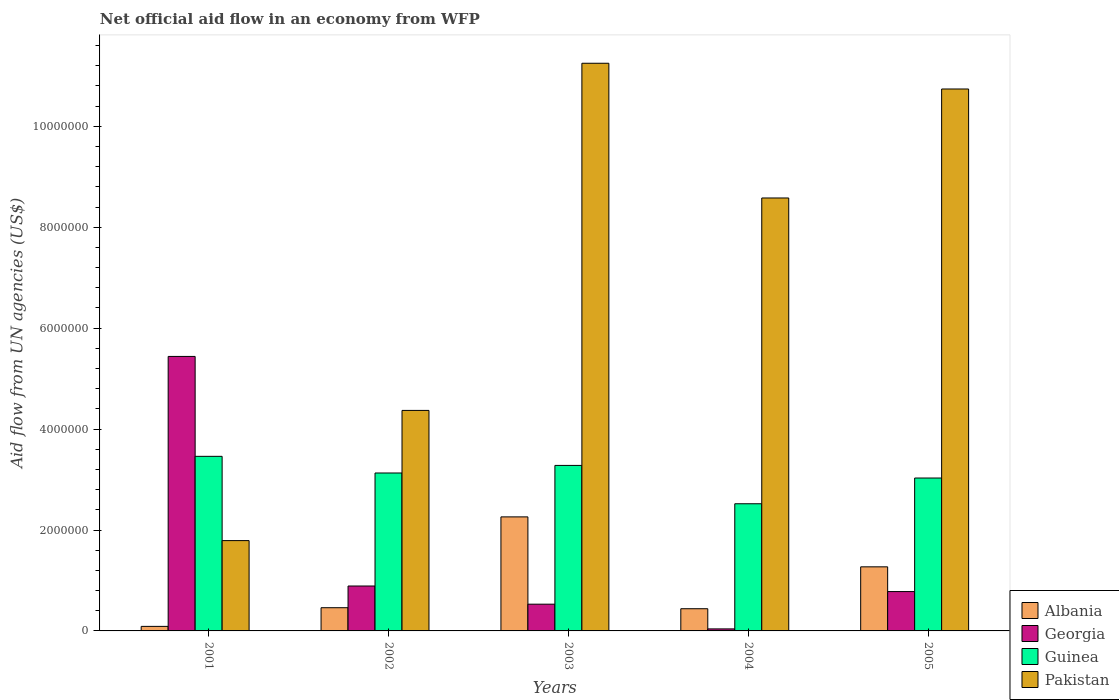How many groups of bars are there?
Ensure brevity in your answer.  5. Are the number of bars per tick equal to the number of legend labels?
Provide a short and direct response. Yes. How many bars are there on the 1st tick from the right?
Provide a short and direct response. 4. What is the label of the 2nd group of bars from the left?
Offer a terse response. 2002. What is the net official aid flow in Pakistan in 2005?
Provide a succinct answer. 1.07e+07. Across all years, what is the maximum net official aid flow in Georgia?
Ensure brevity in your answer.  5.44e+06. What is the total net official aid flow in Pakistan in the graph?
Ensure brevity in your answer.  3.67e+07. What is the difference between the net official aid flow in Guinea in 2001 and that in 2005?
Your answer should be very brief. 4.30e+05. What is the difference between the net official aid flow in Georgia in 2003 and the net official aid flow in Guinea in 2005?
Offer a very short reply. -2.50e+06. What is the average net official aid flow in Pakistan per year?
Your answer should be compact. 7.35e+06. In how many years, is the net official aid flow in Pakistan greater than 6000000 US$?
Offer a terse response. 3. What is the ratio of the net official aid flow in Pakistan in 2003 to that in 2004?
Your answer should be very brief. 1.31. What is the difference between the highest and the second highest net official aid flow in Georgia?
Your answer should be very brief. 4.55e+06. What is the difference between the highest and the lowest net official aid flow in Albania?
Offer a very short reply. 2.17e+06. Is it the case that in every year, the sum of the net official aid flow in Pakistan and net official aid flow in Guinea is greater than the sum of net official aid flow in Georgia and net official aid flow in Albania?
Offer a very short reply. Yes. What does the 1st bar from the left in 2001 represents?
Your answer should be very brief. Albania. What does the 2nd bar from the right in 2001 represents?
Make the answer very short. Guinea. Are all the bars in the graph horizontal?
Provide a succinct answer. No. Are the values on the major ticks of Y-axis written in scientific E-notation?
Provide a short and direct response. No. Does the graph contain grids?
Offer a very short reply. No. Where does the legend appear in the graph?
Your answer should be very brief. Bottom right. How are the legend labels stacked?
Ensure brevity in your answer.  Vertical. What is the title of the graph?
Your response must be concise. Net official aid flow in an economy from WFP. What is the label or title of the X-axis?
Make the answer very short. Years. What is the label or title of the Y-axis?
Offer a terse response. Aid flow from UN agencies (US$). What is the Aid flow from UN agencies (US$) of Georgia in 2001?
Offer a terse response. 5.44e+06. What is the Aid flow from UN agencies (US$) of Guinea in 2001?
Offer a very short reply. 3.46e+06. What is the Aid flow from UN agencies (US$) in Pakistan in 2001?
Ensure brevity in your answer.  1.79e+06. What is the Aid flow from UN agencies (US$) in Albania in 2002?
Your answer should be compact. 4.60e+05. What is the Aid flow from UN agencies (US$) in Georgia in 2002?
Offer a very short reply. 8.90e+05. What is the Aid flow from UN agencies (US$) of Guinea in 2002?
Ensure brevity in your answer.  3.13e+06. What is the Aid flow from UN agencies (US$) of Pakistan in 2002?
Offer a very short reply. 4.37e+06. What is the Aid flow from UN agencies (US$) of Albania in 2003?
Keep it short and to the point. 2.26e+06. What is the Aid flow from UN agencies (US$) in Georgia in 2003?
Ensure brevity in your answer.  5.30e+05. What is the Aid flow from UN agencies (US$) of Guinea in 2003?
Offer a terse response. 3.28e+06. What is the Aid flow from UN agencies (US$) in Pakistan in 2003?
Ensure brevity in your answer.  1.12e+07. What is the Aid flow from UN agencies (US$) in Georgia in 2004?
Offer a very short reply. 4.00e+04. What is the Aid flow from UN agencies (US$) of Guinea in 2004?
Offer a terse response. 2.52e+06. What is the Aid flow from UN agencies (US$) of Pakistan in 2004?
Offer a terse response. 8.58e+06. What is the Aid flow from UN agencies (US$) in Albania in 2005?
Give a very brief answer. 1.27e+06. What is the Aid flow from UN agencies (US$) in Georgia in 2005?
Provide a short and direct response. 7.80e+05. What is the Aid flow from UN agencies (US$) in Guinea in 2005?
Your answer should be very brief. 3.03e+06. What is the Aid flow from UN agencies (US$) in Pakistan in 2005?
Provide a succinct answer. 1.07e+07. Across all years, what is the maximum Aid flow from UN agencies (US$) in Albania?
Provide a short and direct response. 2.26e+06. Across all years, what is the maximum Aid flow from UN agencies (US$) in Georgia?
Keep it short and to the point. 5.44e+06. Across all years, what is the maximum Aid flow from UN agencies (US$) in Guinea?
Your answer should be compact. 3.46e+06. Across all years, what is the maximum Aid flow from UN agencies (US$) of Pakistan?
Make the answer very short. 1.12e+07. Across all years, what is the minimum Aid flow from UN agencies (US$) in Georgia?
Provide a short and direct response. 4.00e+04. Across all years, what is the minimum Aid flow from UN agencies (US$) in Guinea?
Offer a terse response. 2.52e+06. Across all years, what is the minimum Aid flow from UN agencies (US$) of Pakistan?
Your answer should be compact. 1.79e+06. What is the total Aid flow from UN agencies (US$) in Albania in the graph?
Keep it short and to the point. 4.52e+06. What is the total Aid flow from UN agencies (US$) of Georgia in the graph?
Provide a succinct answer. 7.68e+06. What is the total Aid flow from UN agencies (US$) in Guinea in the graph?
Provide a succinct answer. 1.54e+07. What is the total Aid flow from UN agencies (US$) in Pakistan in the graph?
Make the answer very short. 3.67e+07. What is the difference between the Aid flow from UN agencies (US$) in Albania in 2001 and that in 2002?
Provide a short and direct response. -3.70e+05. What is the difference between the Aid flow from UN agencies (US$) in Georgia in 2001 and that in 2002?
Your response must be concise. 4.55e+06. What is the difference between the Aid flow from UN agencies (US$) in Guinea in 2001 and that in 2002?
Offer a very short reply. 3.30e+05. What is the difference between the Aid flow from UN agencies (US$) of Pakistan in 2001 and that in 2002?
Keep it short and to the point. -2.58e+06. What is the difference between the Aid flow from UN agencies (US$) of Albania in 2001 and that in 2003?
Give a very brief answer. -2.17e+06. What is the difference between the Aid flow from UN agencies (US$) of Georgia in 2001 and that in 2003?
Your answer should be very brief. 4.91e+06. What is the difference between the Aid flow from UN agencies (US$) in Pakistan in 2001 and that in 2003?
Provide a short and direct response. -9.46e+06. What is the difference between the Aid flow from UN agencies (US$) in Albania in 2001 and that in 2004?
Offer a terse response. -3.50e+05. What is the difference between the Aid flow from UN agencies (US$) in Georgia in 2001 and that in 2004?
Make the answer very short. 5.40e+06. What is the difference between the Aid flow from UN agencies (US$) in Guinea in 2001 and that in 2004?
Keep it short and to the point. 9.40e+05. What is the difference between the Aid flow from UN agencies (US$) of Pakistan in 2001 and that in 2004?
Provide a succinct answer. -6.79e+06. What is the difference between the Aid flow from UN agencies (US$) of Albania in 2001 and that in 2005?
Offer a very short reply. -1.18e+06. What is the difference between the Aid flow from UN agencies (US$) of Georgia in 2001 and that in 2005?
Offer a terse response. 4.66e+06. What is the difference between the Aid flow from UN agencies (US$) of Pakistan in 2001 and that in 2005?
Give a very brief answer. -8.95e+06. What is the difference between the Aid flow from UN agencies (US$) of Albania in 2002 and that in 2003?
Your answer should be very brief. -1.80e+06. What is the difference between the Aid flow from UN agencies (US$) of Pakistan in 2002 and that in 2003?
Offer a terse response. -6.88e+06. What is the difference between the Aid flow from UN agencies (US$) of Albania in 2002 and that in 2004?
Make the answer very short. 2.00e+04. What is the difference between the Aid flow from UN agencies (US$) of Georgia in 2002 and that in 2004?
Your response must be concise. 8.50e+05. What is the difference between the Aid flow from UN agencies (US$) in Pakistan in 2002 and that in 2004?
Your answer should be very brief. -4.21e+06. What is the difference between the Aid flow from UN agencies (US$) of Albania in 2002 and that in 2005?
Your answer should be very brief. -8.10e+05. What is the difference between the Aid flow from UN agencies (US$) of Georgia in 2002 and that in 2005?
Make the answer very short. 1.10e+05. What is the difference between the Aid flow from UN agencies (US$) of Guinea in 2002 and that in 2005?
Provide a short and direct response. 1.00e+05. What is the difference between the Aid flow from UN agencies (US$) in Pakistan in 2002 and that in 2005?
Provide a short and direct response. -6.37e+06. What is the difference between the Aid flow from UN agencies (US$) in Albania in 2003 and that in 2004?
Provide a short and direct response. 1.82e+06. What is the difference between the Aid flow from UN agencies (US$) of Guinea in 2003 and that in 2004?
Keep it short and to the point. 7.60e+05. What is the difference between the Aid flow from UN agencies (US$) in Pakistan in 2003 and that in 2004?
Your response must be concise. 2.67e+06. What is the difference between the Aid flow from UN agencies (US$) in Albania in 2003 and that in 2005?
Provide a succinct answer. 9.90e+05. What is the difference between the Aid flow from UN agencies (US$) in Pakistan in 2003 and that in 2005?
Provide a succinct answer. 5.10e+05. What is the difference between the Aid flow from UN agencies (US$) of Albania in 2004 and that in 2005?
Your answer should be compact. -8.30e+05. What is the difference between the Aid flow from UN agencies (US$) in Georgia in 2004 and that in 2005?
Your answer should be compact. -7.40e+05. What is the difference between the Aid flow from UN agencies (US$) in Guinea in 2004 and that in 2005?
Offer a terse response. -5.10e+05. What is the difference between the Aid flow from UN agencies (US$) of Pakistan in 2004 and that in 2005?
Your answer should be very brief. -2.16e+06. What is the difference between the Aid flow from UN agencies (US$) in Albania in 2001 and the Aid flow from UN agencies (US$) in Georgia in 2002?
Provide a succinct answer. -8.00e+05. What is the difference between the Aid flow from UN agencies (US$) in Albania in 2001 and the Aid flow from UN agencies (US$) in Guinea in 2002?
Offer a terse response. -3.04e+06. What is the difference between the Aid flow from UN agencies (US$) in Albania in 2001 and the Aid flow from UN agencies (US$) in Pakistan in 2002?
Your answer should be very brief. -4.28e+06. What is the difference between the Aid flow from UN agencies (US$) of Georgia in 2001 and the Aid flow from UN agencies (US$) of Guinea in 2002?
Your answer should be compact. 2.31e+06. What is the difference between the Aid flow from UN agencies (US$) of Georgia in 2001 and the Aid flow from UN agencies (US$) of Pakistan in 2002?
Offer a very short reply. 1.07e+06. What is the difference between the Aid flow from UN agencies (US$) in Guinea in 2001 and the Aid flow from UN agencies (US$) in Pakistan in 2002?
Give a very brief answer. -9.10e+05. What is the difference between the Aid flow from UN agencies (US$) of Albania in 2001 and the Aid flow from UN agencies (US$) of Georgia in 2003?
Provide a succinct answer. -4.40e+05. What is the difference between the Aid flow from UN agencies (US$) of Albania in 2001 and the Aid flow from UN agencies (US$) of Guinea in 2003?
Give a very brief answer. -3.19e+06. What is the difference between the Aid flow from UN agencies (US$) of Albania in 2001 and the Aid flow from UN agencies (US$) of Pakistan in 2003?
Provide a short and direct response. -1.12e+07. What is the difference between the Aid flow from UN agencies (US$) in Georgia in 2001 and the Aid flow from UN agencies (US$) in Guinea in 2003?
Your response must be concise. 2.16e+06. What is the difference between the Aid flow from UN agencies (US$) in Georgia in 2001 and the Aid flow from UN agencies (US$) in Pakistan in 2003?
Provide a short and direct response. -5.81e+06. What is the difference between the Aid flow from UN agencies (US$) in Guinea in 2001 and the Aid flow from UN agencies (US$) in Pakistan in 2003?
Give a very brief answer. -7.79e+06. What is the difference between the Aid flow from UN agencies (US$) in Albania in 2001 and the Aid flow from UN agencies (US$) in Guinea in 2004?
Offer a terse response. -2.43e+06. What is the difference between the Aid flow from UN agencies (US$) of Albania in 2001 and the Aid flow from UN agencies (US$) of Pakistan in 2004?
Provide a short and direct response. -8.49e+06. What is the difference between the Aid flow from UN agencies (US$) in Georgia in 2001 and the Aid flow from UN agencies (US$) in Guinea in 2004?
Provide a succinct answer. 2.92e+06. What is the difference between the Aid flow from UN agencies (US$) of Georgia in 2001 and the Aid flow from UN agencies (US$) of Pakistan in 2004?
Your response must be concise. -3.14e+06. What is the difference between the Aid flow from UN agencies (US$) in Guinea in 2001 and the Aid flow from UN agencies (US$) in Pakistan in 2004?
Offer a terse response. -5.12e+06. What is the difference between the Aid flow from UN agencies (US$) in Albania in 2001 and the Aid flow from UN agencies (US$) in Georgia in 2005?
Offer a very short reply. -6.90e+05. What is the difference between the Aid flow from UN agencies (US$) of Albania in 2001 and the Aid flow from UN agencies (US$) of Guinea in 2005?
Make the answer very short. -2.94e+06. What is the difference between the Aid flow from UN agencies (US$) in Albania in 2001 and the Aid flow from UN agencies (US$) in Pakistan in 2005?
Provide a short and direct response. -1.06e+07. What is the difference between the Aid flow from UN agencies (US$) in Georgia in 2001 and the Aid flow from UN agencies (US$) in Guinea in 2005?
Your answer should be compact. 2.41e+06. What is the difference between the Aid flow from UN agencies (US$) in Georgia in 2001 and the Aid flow from UN agencies (US$) in Pakistan in 2005?
Your answer should be compact. -5.30e+06. What is the difference between the Aid flow from UN agencies (US$) of Guinea in 2001 and the Aid flow from UN agencies (US$) of Pakistan in 2005?
Your response must be concise. -7.28e+06. What is the difference between the Aid flow from UN agencies (US$) in Albania in 2002 and the Aid flow from UN agencies (US$) in Guinea in 2003?
Offer a very short reply. -2.82e+06. What is the difference between the Aid flow from UN agencies (US$) of Albania in 2002 and the Aid flow from UN agencies (US$) of Pakistan in 2003?
Provide a succinct answer. -1.08e+07. What is the difference between the Aid flow from UN agencies (US$) of Georgia in 2002 and the Aid flow from UN agencies (US$) of Guinea in 2003?
Ensure brevity in your answer.  -2.39e+06. What is the difference between the Aid flow from UN agencies (US$) in Georgia in 2002 and the Aid flow from UN agencies (US$) in Pakistan in 2003?
Give a very brief answer. -1.04e+07. What is the difference between the Aid flow from UN agencies (US$) in Guinea in 2002 and the Aid flow from UN agencies (US$) in Pakistan in 2003?
Your answer should be compact. -8.12e+06. What is the difference between the Aid flow from UN agencies (US$) in Albania in 2002 and the Aid flow from UN agencies (US$) in Georgia in 2004?
Provide a succinct answer. 4.20e+05. What is the difference between the Aid flow from UN agencies (US$) in Albania in 2002 and the Aid flow from UN agencies (US$) in Guinea in 2004?
Provide a short and direct response. -2.06e+06. What is the difference between the Aid flow from UN agencies (US$) in Albania in 2002 and the Aid flow from UN agencies (US$) in Pakistan in 2004?
Keep it short and to the point. -8.12e+06. What is the difference between the Aid flow from UN agencies (US$) in Georgia in 2002 and the Aid flow from UN agencies (US$) in Guinea in 2004?
Ensure brevity in your answer.  -1.63e+06. What is the difference between the Aid flow from UN agencies (US$) of Georgia in 2002 and the Aid flow from UN agencies (US$) of Pakistan in 2004?
Provide a short and direct response. -7.69e+06. What is the difference between the Aid flow from UN agencies (US$) in Guinea in 2002 and the Aid flow from UN agencies (US$) in Pakistan in 2004?
Your answer should be compact. -5.45e+06. What is the difference between the Aid flow from UN agencies (US$) in Albania in 2002 and the Aid flow from UN agencies (US$) in Georgia in 2005?
Offer a very short reply. -3.20e+05. What is the difference between the Aid flow from UN agencies (US$) in Albania in 2002 and the Aid flow from UN agencies (US$) in Guinea in 2005?
Ensure brevity in your answer.  -2.57e+06. What is the difference between the Aid flow from UN agencies (US$) of Albania in 2002 and the Aid flow from UN agencies (US$) of Pakistan in 2005?
Your answer should be compact. -1.03e+07. What is the difference between the Aid flow from UN agencies (US$) of Georgia in 2002 and the Aid flow from UN agencies (US$) of Guinea in 2005?
Offer a terse response. -2.14e+06. What is the difference between the Aid flow from UN agencies (US$) in Georgia in 2002 and the Aid flow from UN agencies (US$) in Pakistan in 2005?
Give a very brief answer. -9.85e+06. What is the difference between the Aid flow from UN agencies (US$) in Guinea in 2002 and the Aid flow from UN agencies (US$) in Pakistan in 2005?
Provide a succinct answer. -7.61e+06. What is the difference between the Aid flow from UN agencies (US$) of Albania in 2003 and the Aid flow from UN agencies (US$) of Georgia in 2004?
Your answer should be compact. 2.22e+06. What is the difference between the Aid flow from UN agencies (US$) in Albania in 2003 and the Aid flow from UN agencies (US$) in Guinea in 2004?
Your response must be concise. -2.60e+05. What is the difference between the Aid flow from UN agencies (US$) of Albania in 2003 and the Aid flow from UN agencies (US$) of Pakistan in 2004?
Your answer should be very brief. -6.32e+06. What is the difference between the Aid flow from UN agencies (US$) of Georgia in 2003 and the Aid flow from UN agencies (US$) of Guinea in 2004?
Offer a very short reply. -1.99e+06. What is the difference between the Aid flow from UN agencies (US$) of Georgia in 2003 and the Aid flow from UN agencies (US$) of Pakistan in 2004?
Ensure brevity in your answer.  -8.05e+06. What is the difference between the Aid flow from UN agencies (US$) in Guinea in 2003 and the Aid flow from UN agencies (US$) in Pakistan in 2004?
Provide a short and direct response. -5.30e+06. What is the difference between the Aid flow from UN agencies (US$) of Albania in 2003 and the Aid flow from UN agencies (US$) of Georgia in 2005?
Make the answer very short. 1.48e+06. What is the difference between the Aid flow from UN agencies (US$) in Albania in 2003 and the Aid flow from UN agencies (US$) in Guinea in 2005?
Ensure brevity in your answer.  -7.70e+05. What is the difference between the Aid flow from UN agencies (US$) of Albania in 2003 and the Aid flow from UN agencies (US$) of Pakistan in 2005?
Provide a short and direct response. -8.48e+06. What is the difference between the Aid flow from UN agencies (US$) in Georgia in 2003 and the Aid flow from UN agencies (US$) in Guinea in 2005?
Your answer should be very brief. -2.50e+06. What is the difference between the Aid flow from UN agencies (US$) of Georgia in 2003 and the Aid flow from UN agencies (US$) of Pakistan in 2005?
Provide a short and direct response. -1.02e+07. What is the difference between the Aid flow from UN agencies (US$) of Guinea in 2003 and the Aid flow from UN agencies (US$) of Pakistan in 2005?
Provide a succinct answer. -7.46e+06. What is the difference between the Aid flow from UN agencies (US$) of Albania in 2004 and the Aid flow from UN agencies (US$) of Georgia in 2005?
Your response must be concise. -3.40e+05. What is the difference between the Aid flow from UN agencies (US$) in Albania in 2004 and the Aid flow from UN agencies (US$) in Guinea in 2005?
Make the answer very short. -2.59e+06. What is the difference between the Aid flow from UN agencies (US$) of Albania in 2004 and the Aid flow from UN agencies (US$) of Pakistan in 2005?
Ensure brevity in your answer.  -1.03e+07. What is the difference between the Aid flow from UN agencies (US$) of Georgia in 2004 and the Aid flow from UN agencies (US$) of Guinea in 2005?
Give a very brief answer. -2.99e+06. What is the difference between the Aid flow from UN agencies (US$) of Georgia in 2004 and the Aid flow from UN agencies (US$) of Pakistan in 2005?
Provide a short and direct response. -1.07e+07. What is the difference between the Aid flow from UN agencies (US$) in Guinea in 2004 and the Aid flow from UN agencies (US$) in Pakistan in 2005?
Your response must be concise. -8.22e+06. What is the average Aid flow from UN agencies (US$) in Albania per year?
Provide a short and direct response. 9.04e+05. What is the average Aid flow from UN agencies (US$) of Georgia per year?
Provide a short and direct response. 1.54e+06. What is the average Aid flow from UN agencies (US$) in Guinea per year?
Offer a very short reply. 3.08e+06. What is the average Aid flow from UN agencies (US$) in Pakistan per year?
Give a very brief answer. 7.35e+06. In the year 2001, what is the difference between the Aid flow from UN agencies (US$) in Albania and Aid flow from UN agencies (US$) in Georgia?
Provide a short and direct response. -5.35e+06. In the year 2001, what is the difference between the Aid flow from UN agencies (US$) of Albania and Aid flow from UN agencies (US$) of Guinea?
Keep it short and to the point. -3.37e+06. In the year 2001, what is the difference between the Aid flow from UN agencies (US$) of Albania and Aid flow from UN agencies (US$) of Pakistan?
Give a very brief answer. -1.70e+06. In the year 2001, what is the difference between the Aid flow from UN agencies (US$) in Georgia and Aid flow from UN agencies (US$) in Guinea?
Provide a short and direct response. 1.98e+06. In the year 2001, what is the difference between the Aid flow from UN agencies (US$) of Georgia and Aid flow from UN agencies (US$) of Pakistan?
Give a very brief answer. 3.65e+06. In the year 2001, what is the difference between the Aid flow from UN agencies (US$) in Guinea and Aid flow from UN agencies (US$) in Pakistan?
Your response must be concise. 1.67e+06. In the year 2002, what is the difference between the Aid flow from UN agencies (US$) of Albania and Aid flow from UN agencies (US$) of Georgia?
Provide a succinct answer. -4.30e+05. In the year 2002, what is the difference between the Aid flow from UN agencies (US$) in Albania and Aid flow from UN agencies (US$) in Guinea?
Give a very brief answer. -2.67e+06. In the year 2002, what is the difference between the Aid flow from UN agencies (US$) in Albania and Aid flow from UN agencies (US$) in Pakistan?
Offer a very short reply. -3.91e+06. In the year 2002, what is the difference between the Aid flow from UN agencies (US$) of Georgia and Aid flow from UN agencies (US$) of Guinea?
Ensure brevity in your answer.  -2.24e+06. In the year 2002, what is the difference between the Aid flow from UN agencies (US$) in Georgia and Aid flow from UN agencies (US$) in Pakistan?
Give a very brief answer. -3.48e+06. In the year 2002, what is the difference between the Aid flow from UN agencies (US$) of Guinea and Aid flow from UN agencies (US$) of Pakistan?
Give a very brief answer. -1.24e+06. In the year 2003, what is the difference between the Aid flow from UN agencies (US$) in Albania and Aid flow from UN agencies (US$) in Georgia?
Make the answer very short. 1.73e+06. In the year 2003, what is the difference between the Aid flow from UN agencies (US$) of Albania and Aid flow from UN agencies (US$) of Guinea?
Your response must be concise. -1.02e+06. In the year 2003, what is the difference between the Aid flow from UN agencies (US$) of Albania and Aid flow from UN agencies (US$) of Pakistan?
Offer a very short reply. -8.99e+06. In the year 2003, what is the difference between the Aid flow from UN agencies (US$) of Georgia and Aid flow from UN agencies (US$) of Guinea?
Provide a succinct answer. -2.75e+06. In the year 2003, what is the difference between the Aid flow from UN agencies (US$) of Georgia and Aid flow from UN agencies (US$) of Pakistan?
Make the answer very short. -1.07e+07. In the year 2003, what is the difference between the Aid flow from UN agencies (US$) of Guinea and Aid flow from UN agencies (US$) of Pakistan?
Offer a very short reply. -7.97e+06. In the year 2004, what is the difference between the Aid flow from UN agencies (US$) of Albania and Aid flow from UN agencies (US$) of Georgia?
Keep it short and to the point. 4.00e+05. In the year 2004, what is the difference between the Aid flow from UN agencies (US$) of Albania and Aid flow from UN agencies (US$) of Guinea?
Give a very brief answer. -2.08e+06. In the year 2004, what is the difference between the Aid flow from UN agencies (US$) of Albania and Aid flow from UN agencies (US$) of Pakistan?
Ensure brevity in your answer.  -8.14e+06. In the year 2004, what is the difference between the Aid flow from UN agencies (US$) of Georgia and Aid flow from UN agencies (US$) of Guinea?
Give a very brief answer. -2.48e+06. In the year 2004, what is the difference between the Aid flow from UN agencies (US$) in Georgia and Aid flow from UN agencies (US$) in Pakistan?
Your answer should be very brief. -8.54e+06. In the year 2004, what is the difference between the Aid flow from UN agencies (US$) in Guinea and Aid flow from UN agencies (US$) in Pakistan?
Offer a terse response. -6.06e+06. In the year 2005, what is the difference between the Aid flow from UN agencies (US$) in Albania and Aid flow from UN agencies (US$) in Georgia?
Your answer should be compact. 4.90e+05. In the year 2005, what is the difference between the Aid flow from UN agencies (US$) in Albania and Aid flow from UN agencies (US$) in Guinea?
Your answer should be very brief. -1.76e+06. In the year 2005, what is the difference between the Aid flow from UN agencies (US$) in Albania and Aid flow from UN agencies (US$) in Pakistan?
Offer a very short reply. -9.47e+06. In the year 2005, what is the difference between the Aid flow from UN agencies (US$) of Georgia and Aid flow from UN agencies (US$) of Guinea?
Your answer should be very brief. -2.25e+06. In the year 2005, what is the difference between the Aid flow from UN agencies (US$) in Georgia and Aid flow from UN agencies (US$) in Pakistan?
Ensure brevity in your answer.  -9.96e+06. In the year 2005, what is the difference between the Aid flow from UN agencies (US$) of Guinea and Aid flow from UN agencies (US$) of Pakistan?
Your answer should be compact. -7.71e+06. What is the ratio of the Aid flow from UN agencies (US$) in Albania in 2001 to that in 2002?
Provide a short and direct response. 0.2. What is the ratio of the Aid flow from UN agencies (US$) of Georgia in 2001 to that in 2002?
Your answer should be compact. 6.11. What is the ratio of the Aid flow from UN agencies (US$) in Guinea in 2001 to that in 2002?
Keep it short and to the point. 1.11. What is the ratio of the Aid flow from UN agencies (US$) of Pakistan in 2001 to that in 2002?
Ensure brevity in your answer.  0.41. What is the ratio of the Aid flow from UN agencies (US$) of Albania in 2001 to that in 2003?
Make the answer very short. 0.04. What is the ratio of the Aid flow from UN agencies (US$) of Georgia in 2001 to that in 2003?
Offer a very short reply. 10.26. What is the ratio of the Aid flow from UN agencies (US$) in Guinea in 2001 to that in 2003?
Provide a succinct answer. 1.05. What is the ratio of the Aid flow from UN agencies (US$) of Pakistan in 2001 to that in 2003?
Your answer should be very brief. 0.16. What is the ratio of the Aid flow from UN agencies (US$) in Albania in 2001 to that in 2004?
Make the answer very short. 0.2. What is the ratio of the Aid flow from UN agencies (US$) in Georgia in 2001 to that in 2004?
Keep it short and to the point. 136. What is the ratio of the Aid flow from UN agencies (US$) in Guinea in 2001 to that in 2004?
Offer a very short reply. 1.37. What is the ratio of the Aid flow from UN agencies (US$) of Pakistan in 2001 to that in 2004?
Keep it short and to the point. 0.21. What is the ratio of the Aid flow from UN agencies (US$) in Albania in 2001 to that in 2005?
Ensure brevity in your answer.  0.07. What is the ratio of the Aid flow from UN agencies (US$) in Georgia in 2001 to that in 2005?
Provide a short and direct response. 6.97. What is the ratio of the Aid flow from UN agencies (US$) in Guinea in 2001 to that in 2005?
Your response must be concise. 1.14. What is the ratio of the Aid flow from UN agencies (US$) of Albania in 2002 to that in 2003?
Offer a terse response. 0.2. What is the ratio of the Aid flow from UN agencies (US$) in Georgia in 2002 to that in 2003?
Your response must be concise. 1.68. What is the ratio of the Aid flow from UN agencies (US$) in Guinea in 2002 to that in 2003?
Provide a succinct answer. 0.95. What is the ratio of the Aid flow from UN agencies (US$) of Pakistan in 2002 to that in 2003?
Offer a very short reply. 0.39. What is the ratio of the Aid flow from UN agencies (US$) in Albania in 2002 to that in 2004?
Your answer should be compact. 1.05. What is the ratio of the Aid flow from UN agencies (US$) of Georgia in 2002 to that in 2004?
Keep it short and to the point. 22.25. What is the ratio of the Aid flow from UN agencies (US$) of Guinea in 2002 to that in 2004?
Provide a short and direct response. 1.24. What is the ratio of the Aid flow from UN agencies (US$) in Pakistan in 2002 to that in 2004?
Your answer should be very brief. 0.51. What is the ratio of the Aid flow from UN agencies (US$) in Albania in 2002 to that in 2005?
Give a very brief answer. 0.36. What is the ratio of the Aid flow from UN agencies (US$) of Georgia in 2002 to that in 2005?
Provide a short and direct response. 1.14. What is the ratio of the Aid flow from UN agencies (US$) of Guinea in 2002 to that in 2005?
Provide a succinct answer. 1.03. What is the ratio of the Aid flow from UN agencies (US$) in Pakistan in 2002 to that in 2005?
Make the answer very short. 0.41. What is the ratio of the Aid flow from UN agencies (US$) of Albania in 2003 to that in 2004?
Give a very brief answer. 5.14. What is the ratio of the Aid flow from UN agencies (US$) of Georgia in 2003 to that in 2004?
Make the answer very short. 13.25. What is the ratio of the Aid flow from UN agencies (US$) in Guinea in 2003 to that in 2004?
Make the answer very short. 1.3. What is the ratio of the Aid flow from UN agencies (US$) in Pakistan in 2003 to that in 2004?
Your response must be concise. 1.31. What is the ratio of the Aid flow from UN agencies (US$) of Albania in 2003 to that in 2005?
Keep it short and to the point. 1.78. What is the ratio of the Aid flow from UN agencies (US$) in Georgia in 2003 to that in 2005?
Keep it short and to the point. 0.68. What is the ratio of the Aid flow from UN agencies (US$) of Guinea in 2003 to that in 2005?
Provide a succinct answer. 1.08. What is the ratio of the Aid flow from UN agencies (US$) of Pakistan in 2003 to that in 2005?
Keep it short and to the point. 1.05. What is the ratio of the Aid flow from UN agencies (US$) in Albania in 2004 to that in 2005?
Offer a very short reply. 0.35. What is the ratio of the Aid flow from UN agencies (US$) of Georgia in 2004 to that in 2005?
Your response must be concise. 0.05. What is the ratio of the Aid flow from UN agencies (US$) in Guinea in 2004 to that in 2005?
Provide a short and direct response. 0.83. What is the ratio of the Aid flow from UN agencies (US$) in Pakistan in 2004 to that in 2005?
Offer a terse response. 0.8. What is the difference between the highest and the second highest Aid flow from UN agencies (US$) of Albania?
Provide a succinct answer. 9.90e+05. What is the difference between the highest and the second highest Aid flow from UN agencies (US$) in Georgia?
Your response must be concise. 4.55e+06. What is the difference between the highest and the second highest Aid flow from UN agencies (US$) in Guinea?
Your answer should be very brief. 1.80e+05. What is the difference between the highest and the second highest Aid flow from UN agencies (US$) in Pakistan?
Offer a very short reply. 5.10e+05. What is the difference between the highest and the lowest Aid flow from UN agencies (US$) of Albania?
Offer a very short reply. 2.17e+06. What is the difference between the highest and the lowest Aid flow from UN agencies (US$) in Georgia?
Your response must be concise. 5.40e+06. What is the difference between the highest and the lowest Aid flow from UN agencies (US$) of Guinea?
Give a very brief answer. 9.40e+05. What is the difference between the highest and the lowest Aid flow from UN agencies (US$) in Pakistan?
Your answer should be very brief. 9.46e+06. 